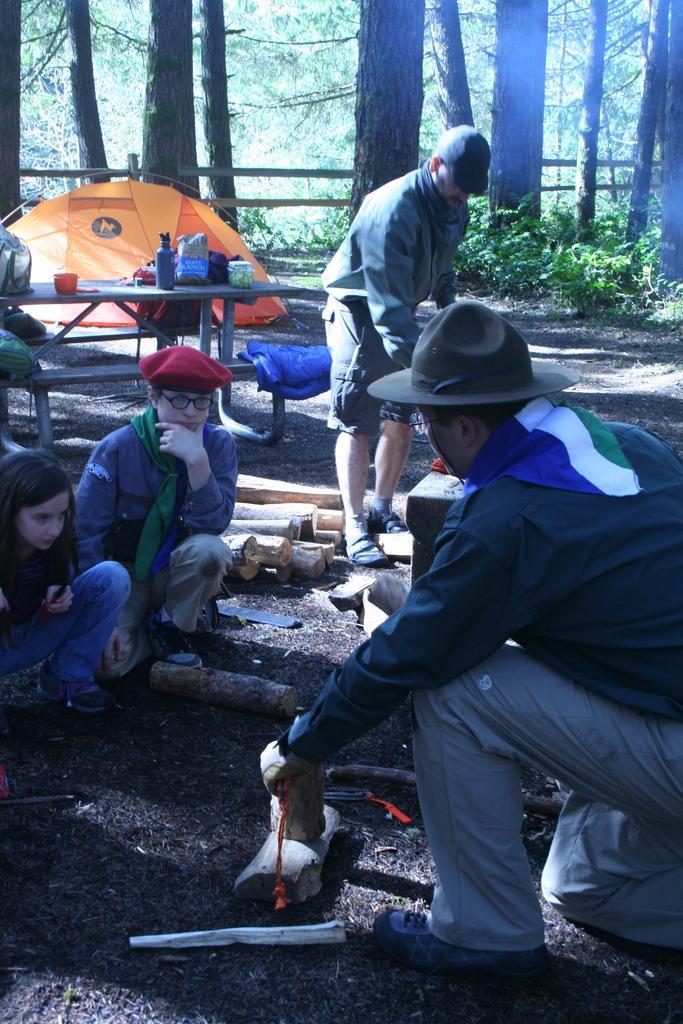Describe this image in one or two sentences. In this picture I can see a few people on the surface. I can see wooden table and bench. I can see the tent on the left side. I can see trees. I can see wooden objects on the surface. 